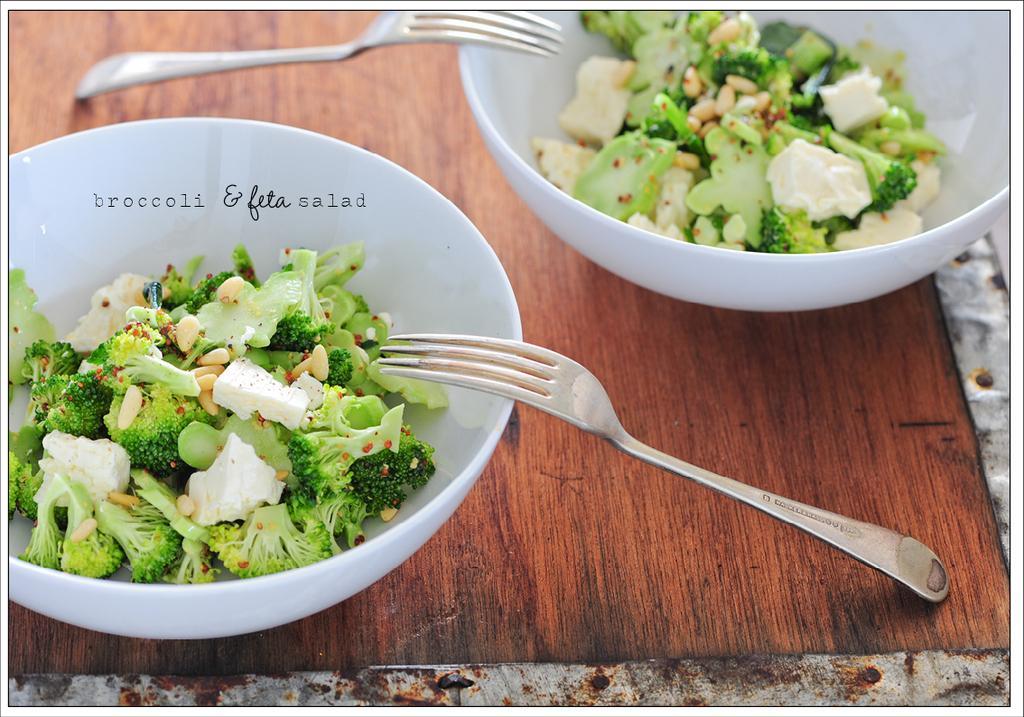Describe this image in one or two sentences. In this picture we can see two bowls, there are some pieces of broccoli and some other food present in these bowls, we can see two forks here, at the bottom there is a table. 